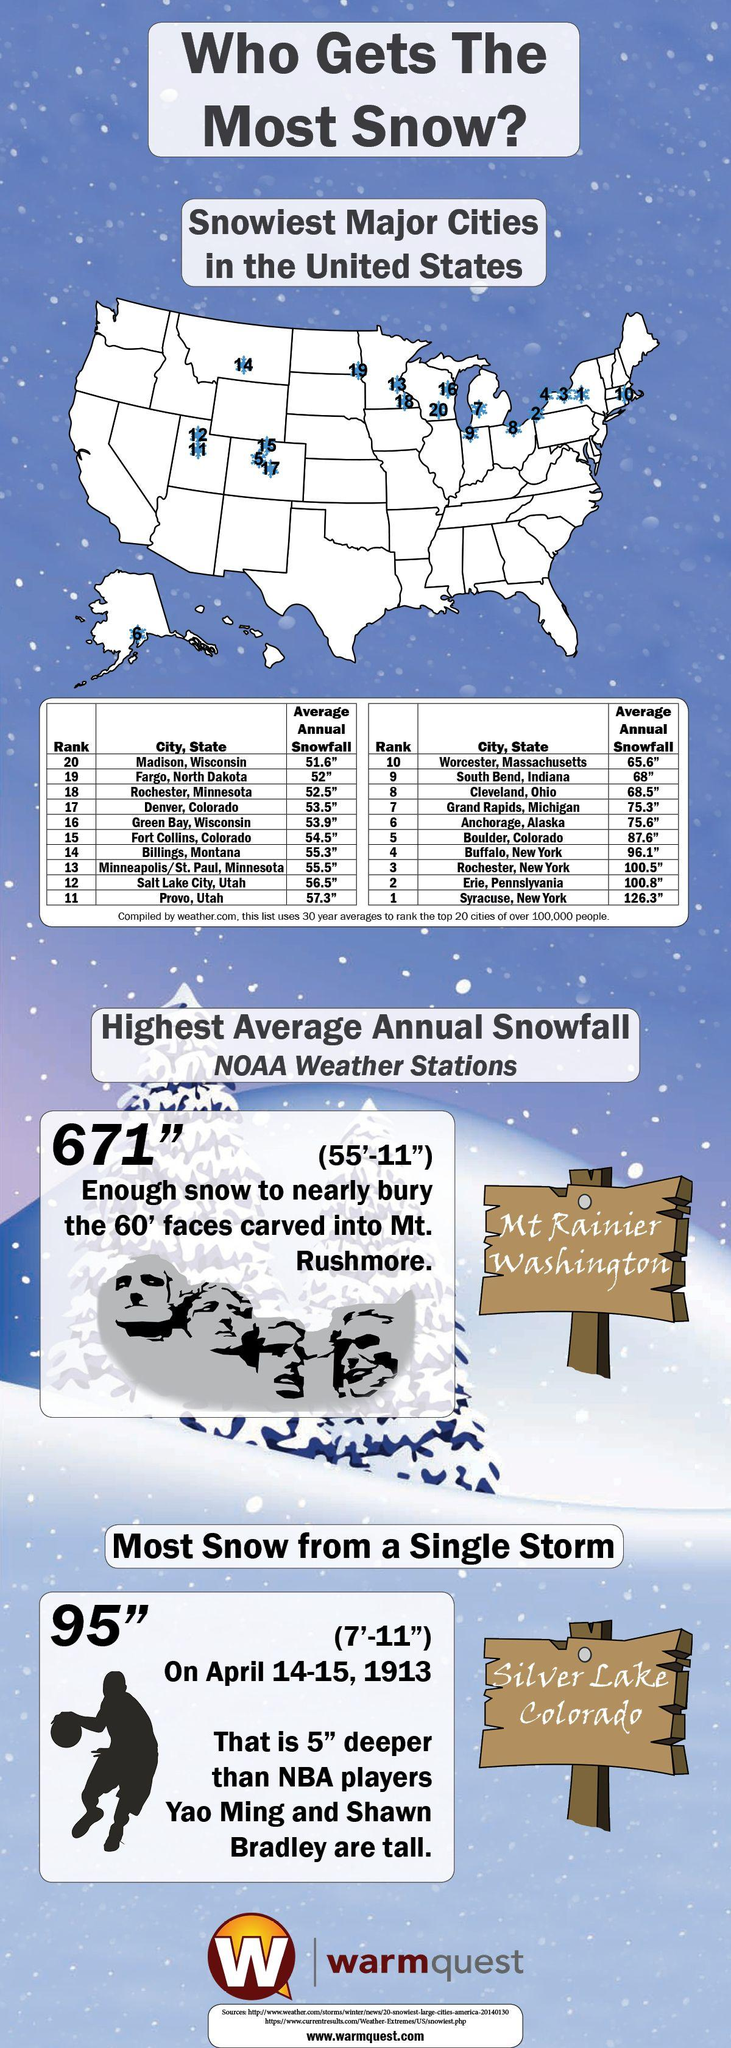Point out several critical features in this image. According to data, Syracuse, New York records the highest average annual snowfall in the United States. Salt Lake City, Utah is ranked the 12th city in the United States with the highest average annual snowfall. According to records, the second least average annual snowfall recorded in the United States is 52. In the United States, the least amount of annual snowfall recorded was 51.6 inches. Pennsylvania records the second highest average annual snowfall in the United States. 